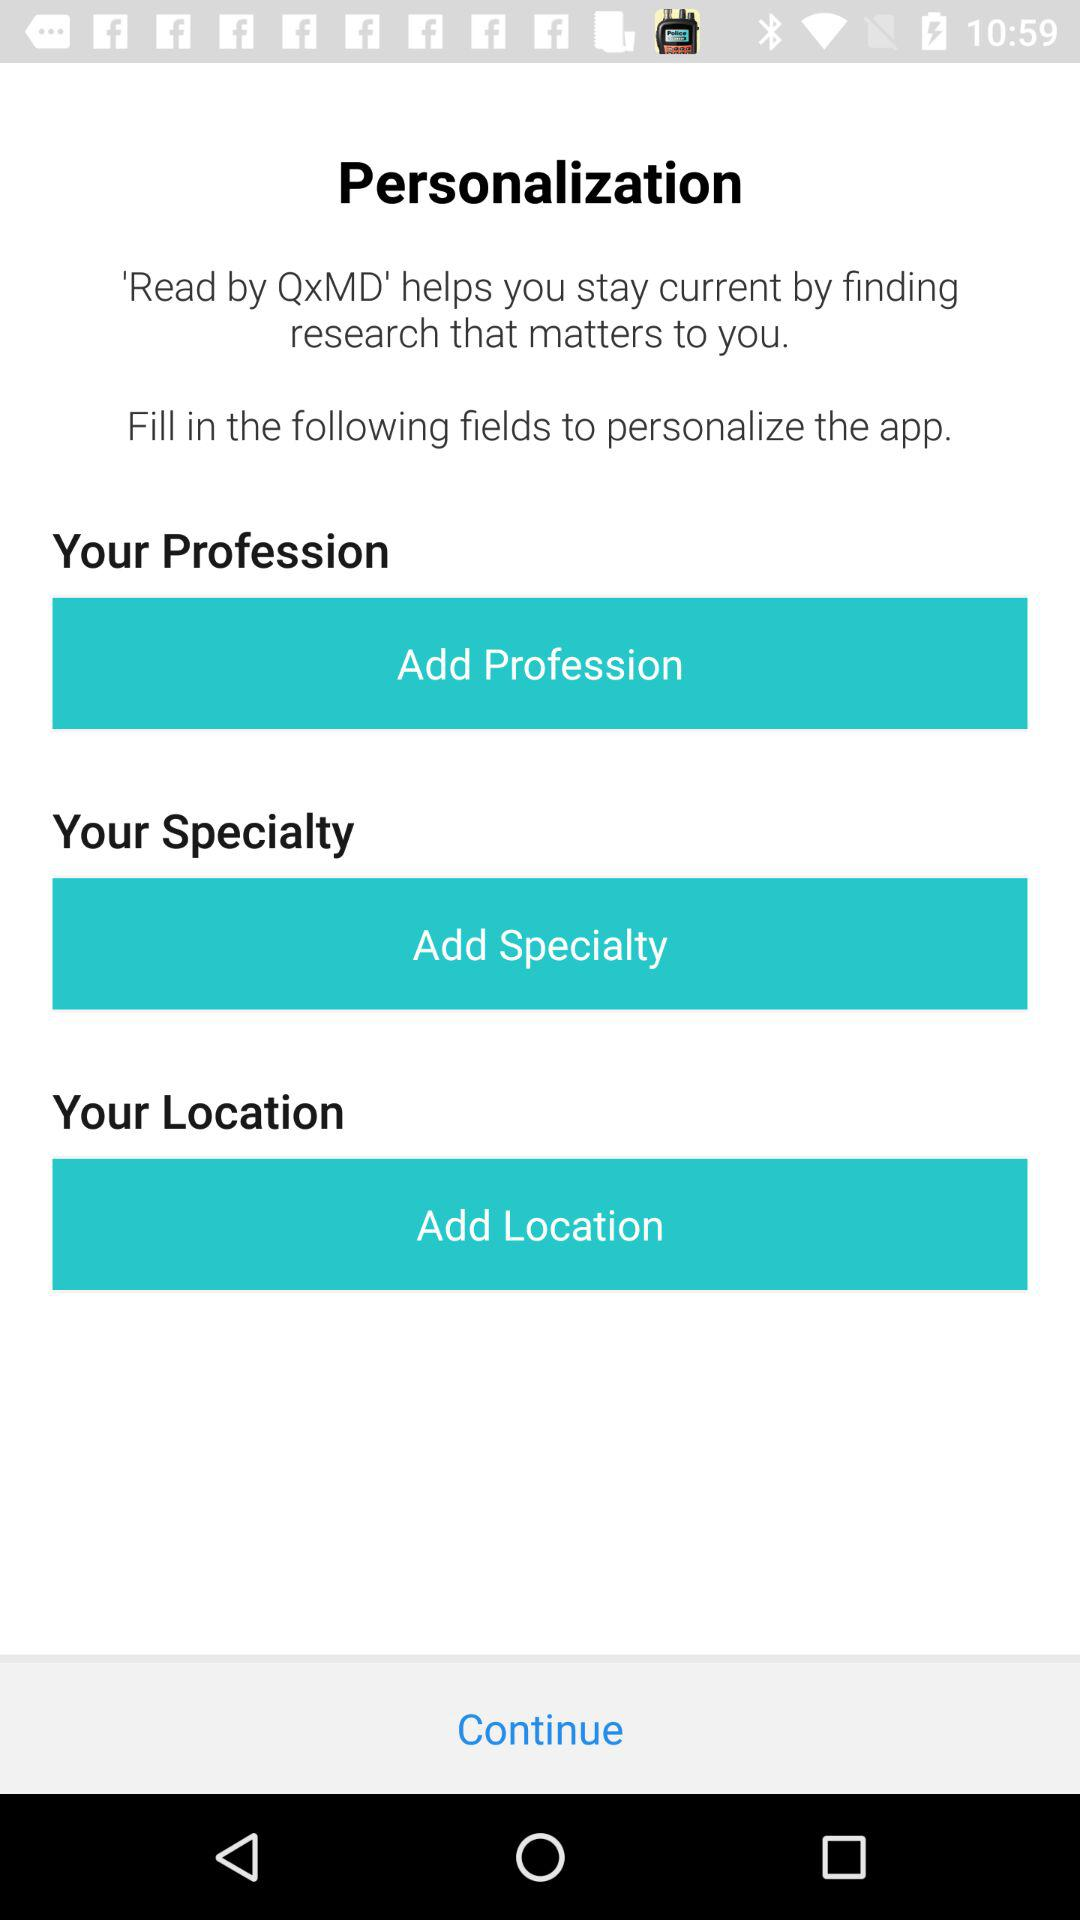What is the name of the application? The name of the application is "Read by QxMD". 